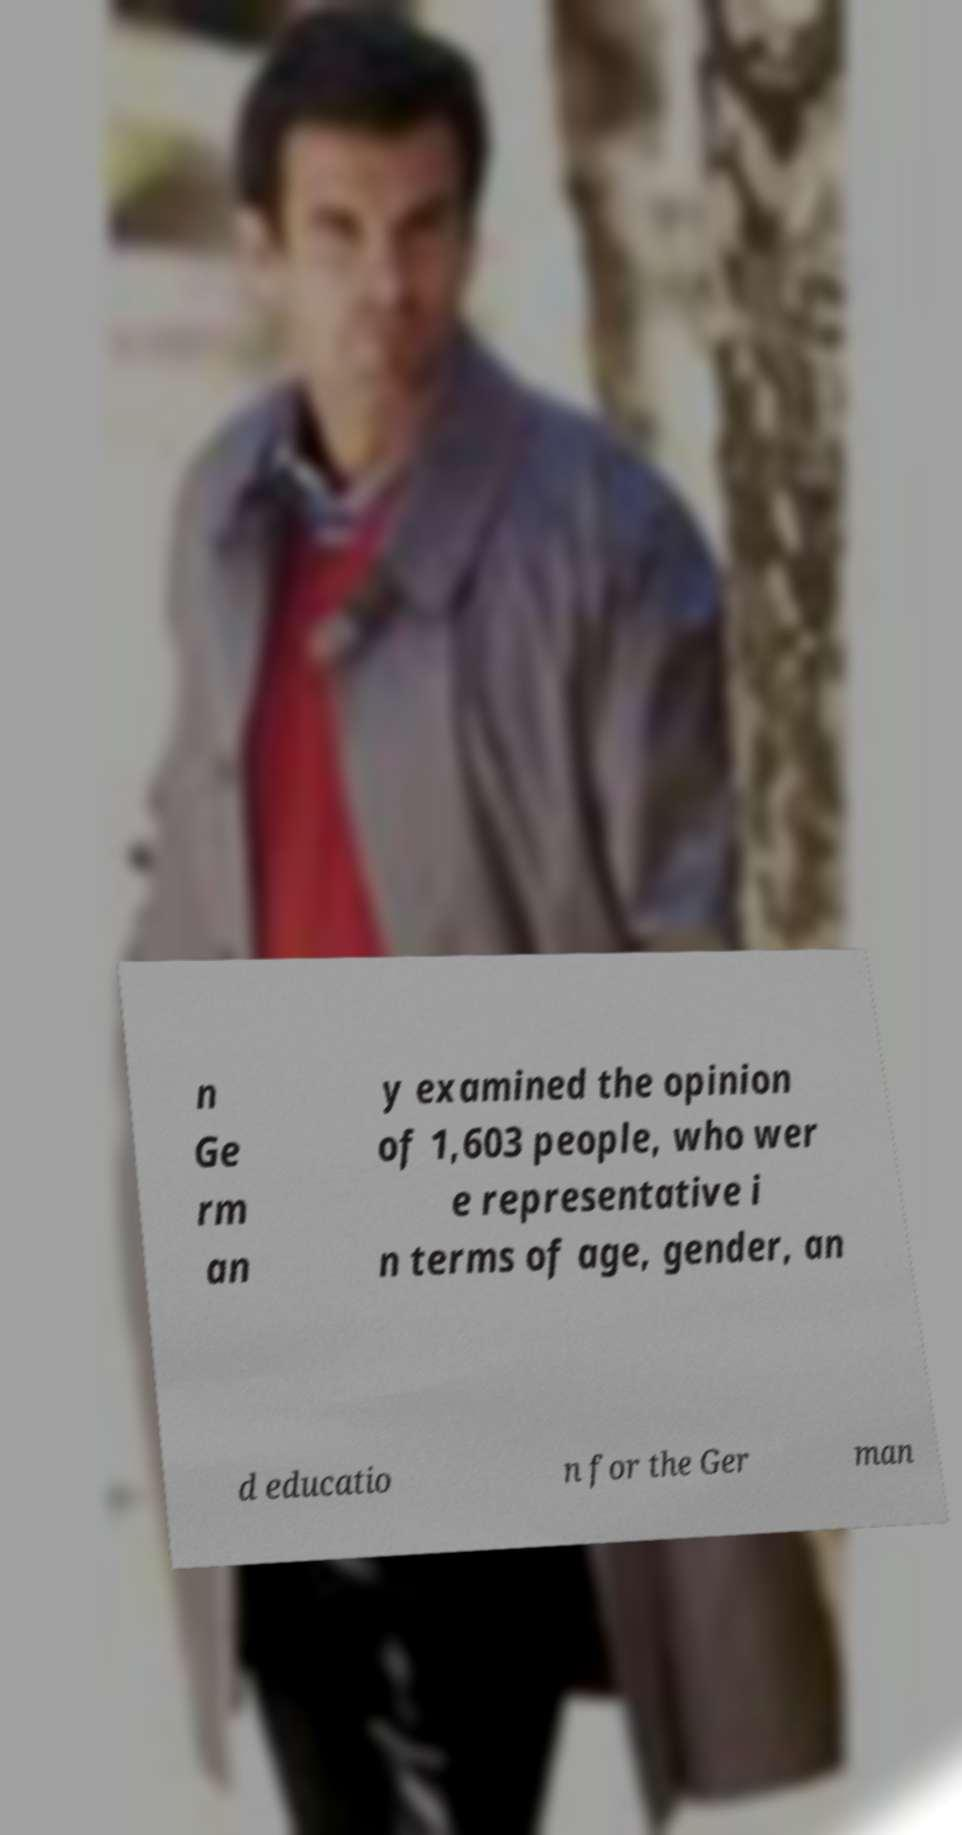What messages or text are displayed in this image? I need them in a readable, typed format. n Ge rm an y examined the opinion of 1,603 people, who wer e representative i n terms of age, gender, an d educatio n for the Ger man 